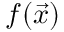<formula> <loc_0><loc_0><loc_500><loc_500>f ( \vec { x } )</formula> 